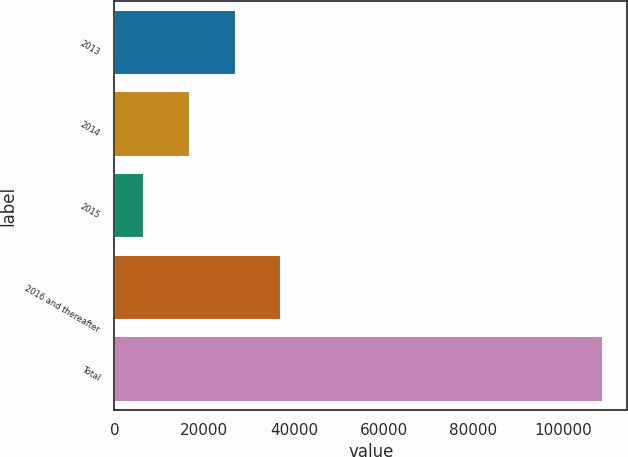<chart> <loc_0><loc_0><loc_500><loc_500><bar_chart><fcel>2013<fcel>2014<fcel>2015<fcel>2016 and thereafter<fcel>Total<nl><fcel>27001.4<fcel>16767.7<fcel>6534<fcel>37235.1<fcel>108871<nl></chart> 